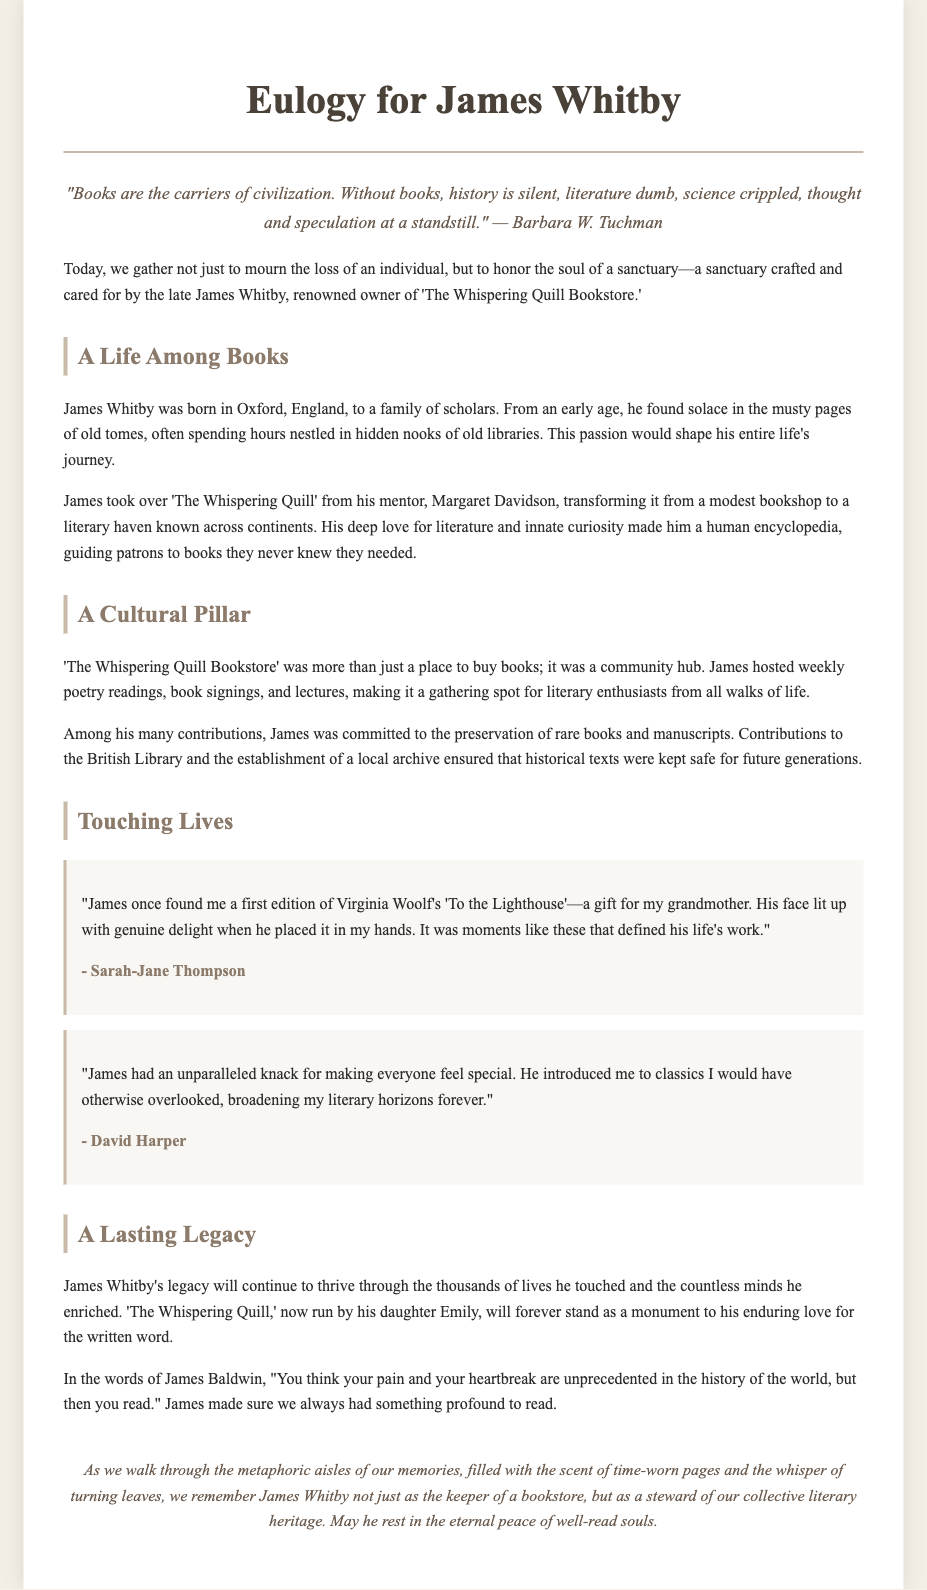What was the name of the bookstore owned by James Whitby? The name of the bookstore is mentioned as 'The Whispering Quill Bookstore.'
Answer: 'The Whispering Quill Bookstore' Who did James Whitby inherit the bookstore from? The document specifies that he took over 'The Whispering Quill' from his mentor, Margaret Davidson.
Answer: Margaret Davidson Which city did James Whitby grow up in? The document states he was born in Oxford, England.
Answer: Oxford, England What type of events did James host at his bookstore? The document mentions that he hosted weekly poetry readings, book signings, and lectures.
Answer: poetry readings, book signings, lectures Who is running the bookstore now? The document indicates that the bookstore is now run by his daughter, Emily.
Answer: Emily What was James Whitby's contribution to literature preservation? It mentions that he was committed to the preservation of rare books and manuscripts, contributing to the British Library.
Answer: preservation of rare books and manuscripts What emotion did Sarah-Jane Thompson associate with her experience at the bookstore? The excerpt from Sarah-Jane Thompson describes James's face lighting up with genuine delight when he found her the book.
Answer: genuine delight What does the eulogy suggest about James Whitby's impact on the community? It notes that he made 'The Whispering Quill' a gathering spot for literary enthusiasts from all walks of life.
Answer: gathering spot for literary enthusiasts What overarching theme does the eulogy convey about James Whitby as a person? The document portrays him as a steward of our collective literary heritage.
Answer: steward of our collective literary heritage 